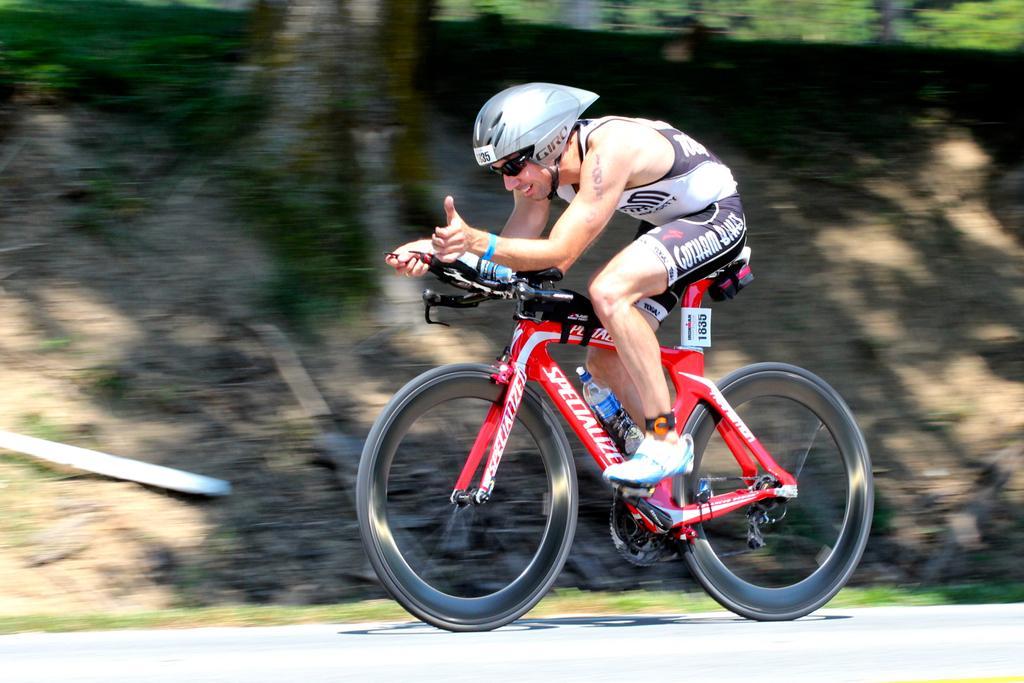Can you describe this image briefly? In the center of the image we can see one person is riding a cycle. And he is wearing a helmet and he is smiling. On the cycle, we can see one water bottle. In the background we can see the grass and a few other objects. 